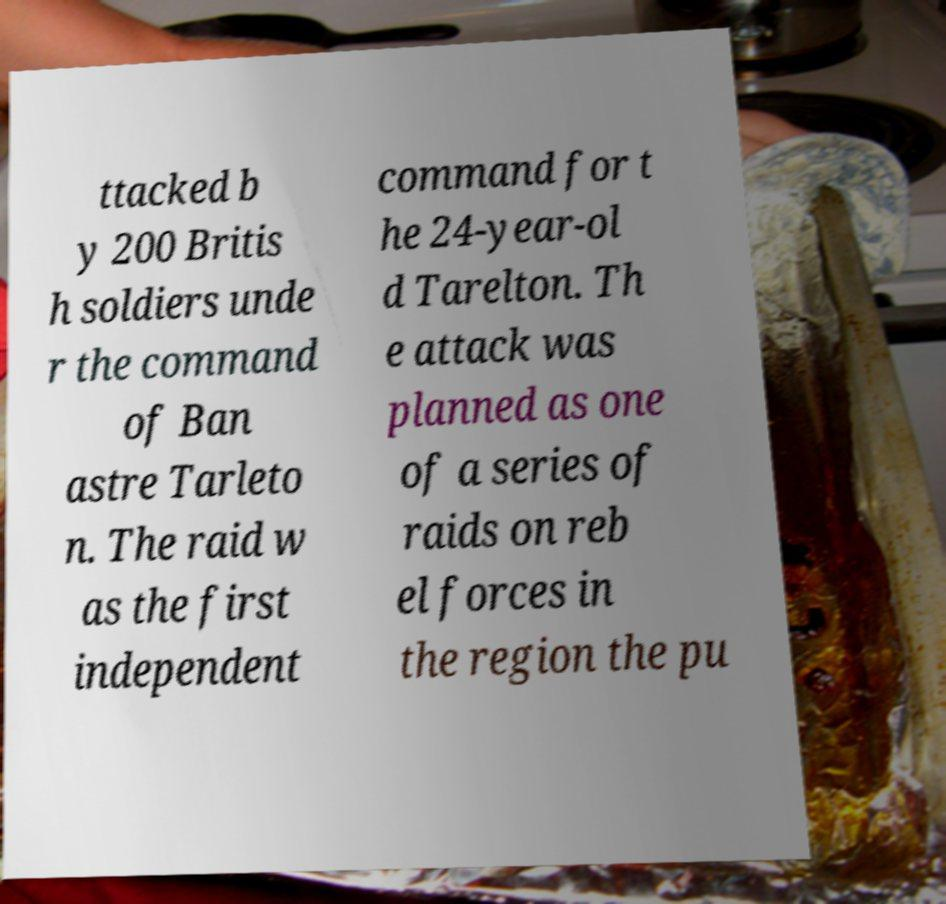Please read and relay the text visible in this image. What does it say? ttacked b y 200 Britis h soldiers unde r the command of Ban astre Tarleto n. The raid w as the first independent command for t he 24-year-ol d Tarelton. Th e attack was planned as one of a series of raids on reb el forces in the region the pu 